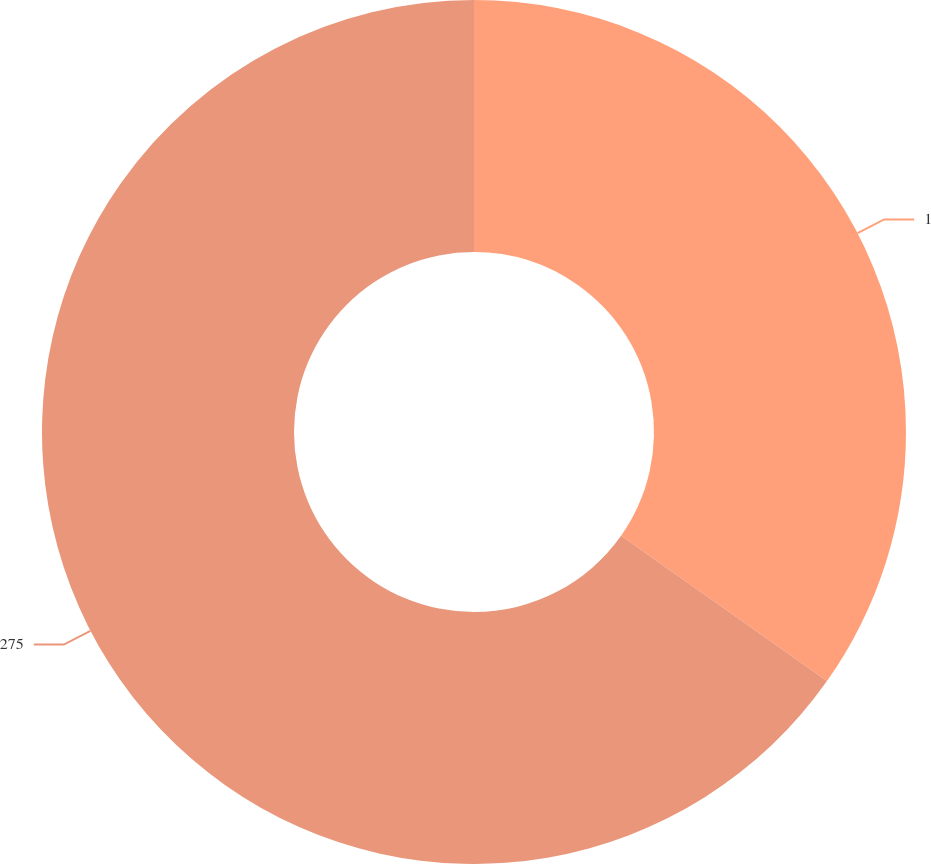<chart> <loc_0><loc_0><loc_500><loc_500><pie_chart><fcel>1<fcel>275<nl><fcel>34.78%<fcel>65.22%<nl></chart> 